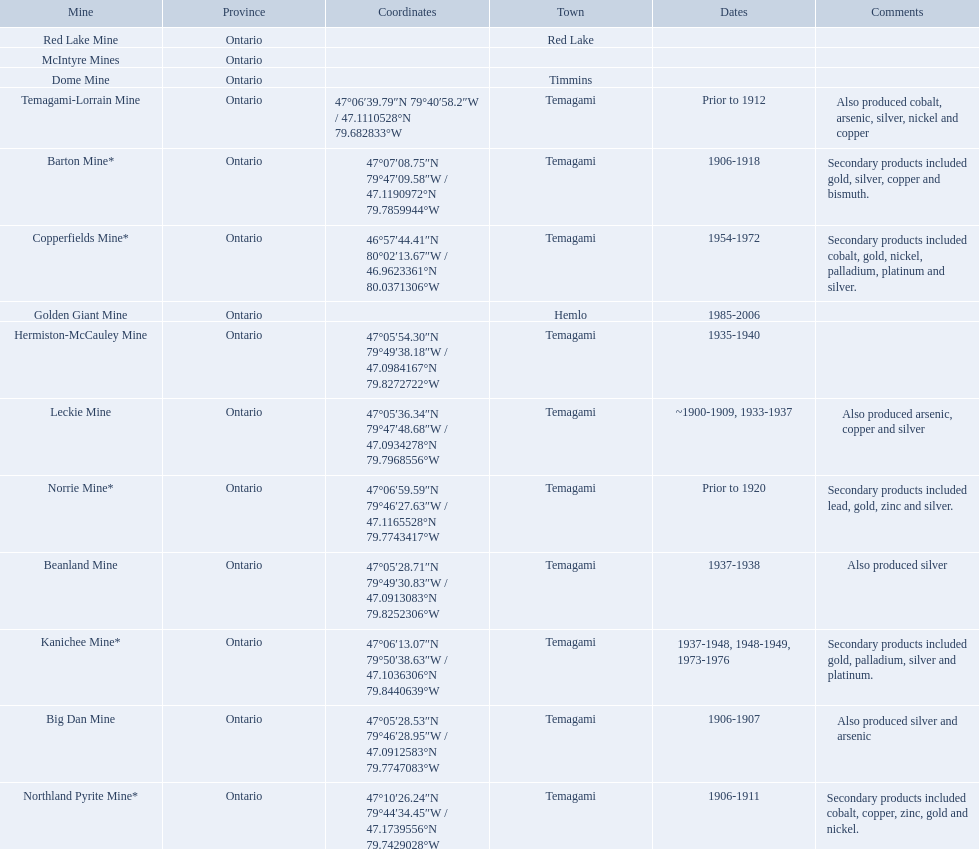What years was the golden giant mine open for? 1985-2006. What years was the beanland mine open? 1937-1938. Which of these two mines was open longer? Golden Giant Mine. 